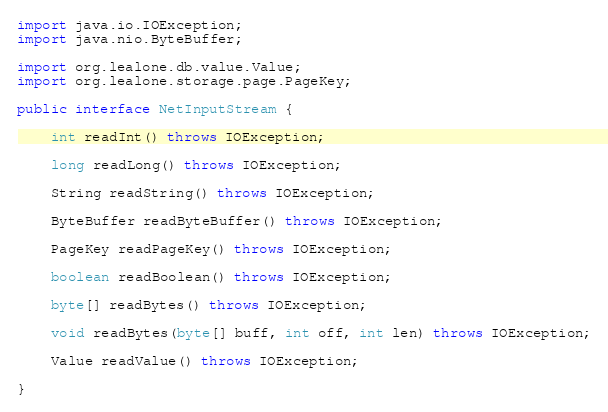<code> <loc_0><loc_0><loc_500><loc_500><_Java_>import java.io.IOException;
import java.nio.ByteBuffer;

import org.lealone.db.value.Value;
import org.lealone.storage.page.PageKey;

public interface NetInputStream {

    int readInt() throws IOException;

    long readLong() throws IOException;

    String readString() throws IOException;

    ByteBuffer readByteBuffer() throws IOException;

    PageKey readPageKey() throws IOException;

    boolean readBoolean() throws IOException;

    byte[] readBytes() throws IOException;

    void readBytes(byte[] buff, int off, int len) throws IOException;

    Value readValue() throws IOException;

}
</code> 